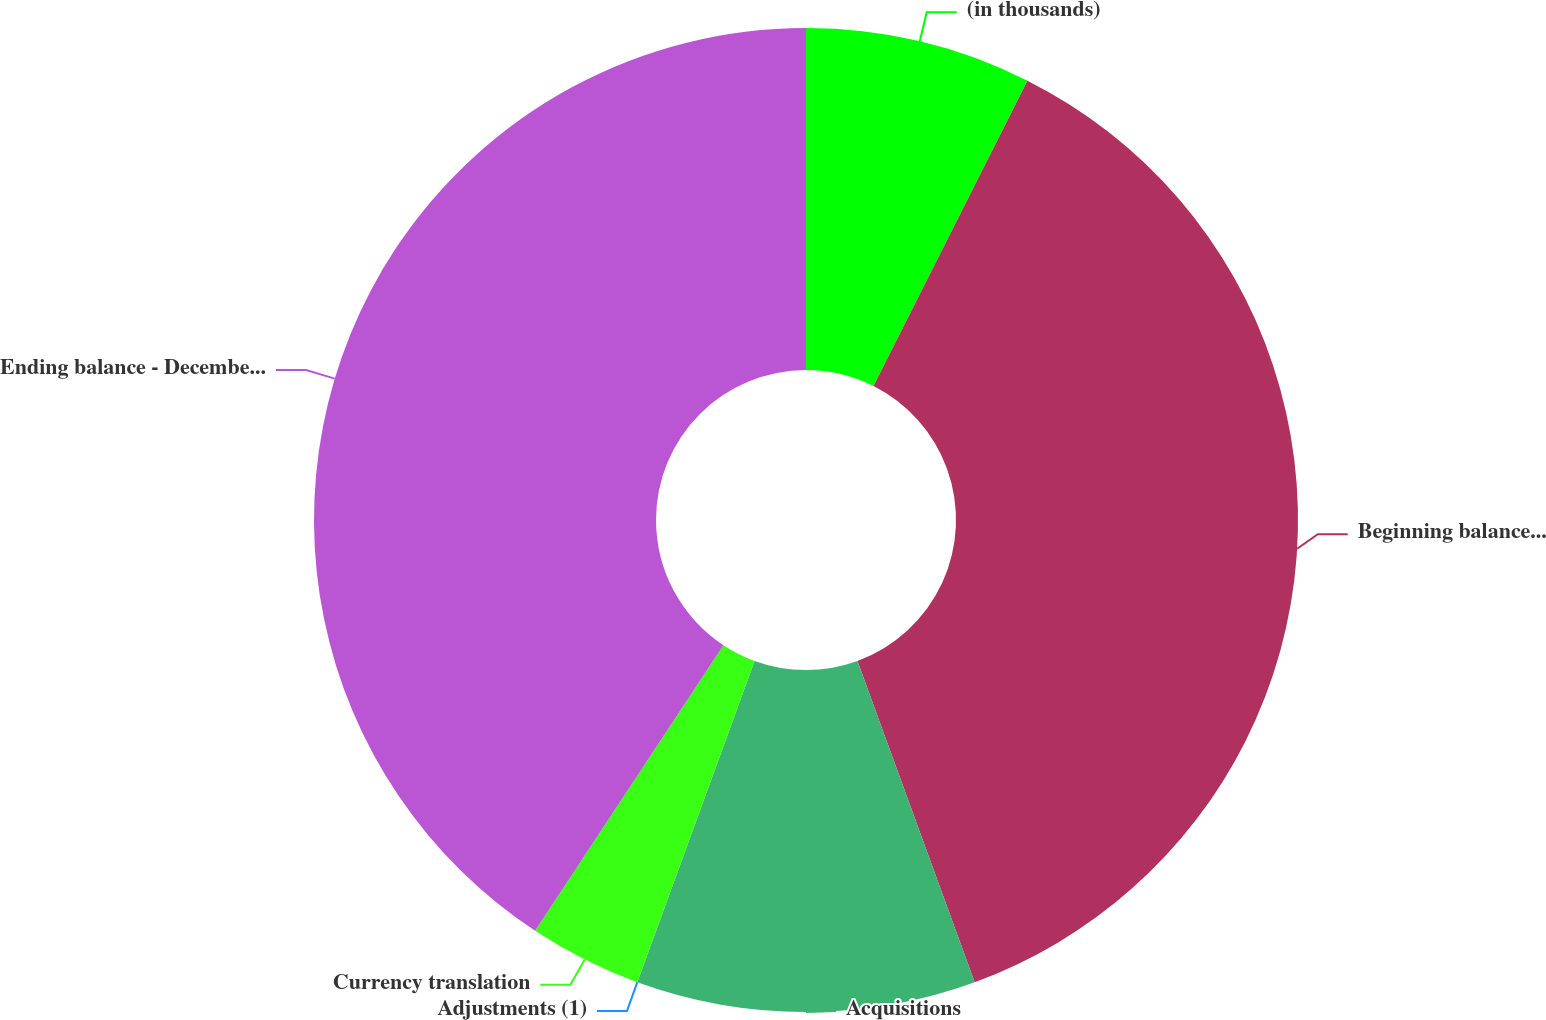<chart> <loc_0><loc_0><loc_500><loc_500><pie_chart><fcel>(in thousands)<fcel>Beginning balance - January 1<fcel>Acquisitions<fcel>Adjustments (1)<fcel>Currency translation<fcel>Ending balance - December 31<nl><fcel>7.43%<fcel>37.0%<fcel>11.14%<fcel>0.0%<fcel>3.71%<fcel>40.72%<nl></chart> 